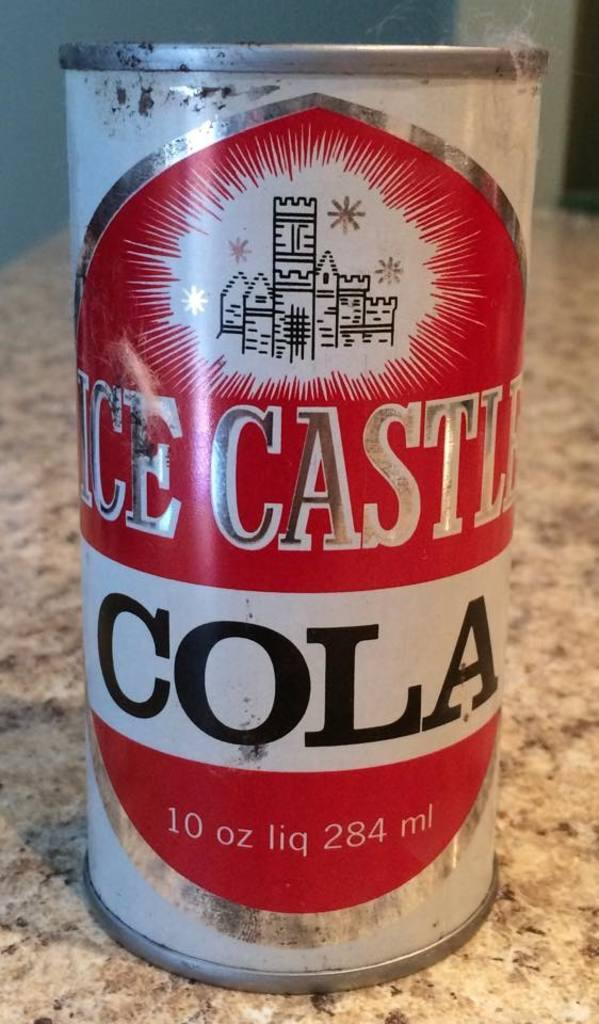<image>
Write a terse but informative summary of the picture. A can of cola sitting on a marble bench top. 